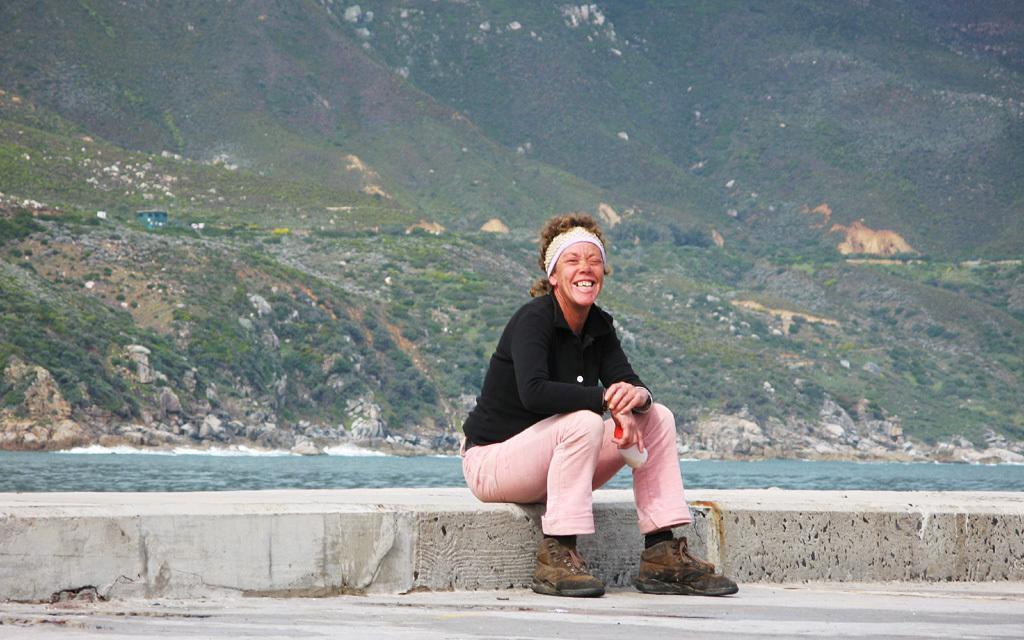Please provide a concise description of this image. In this picture we can see a person holding an object and sitting on a platform and smiling, rocks, plants and in the background we can see mountains. 